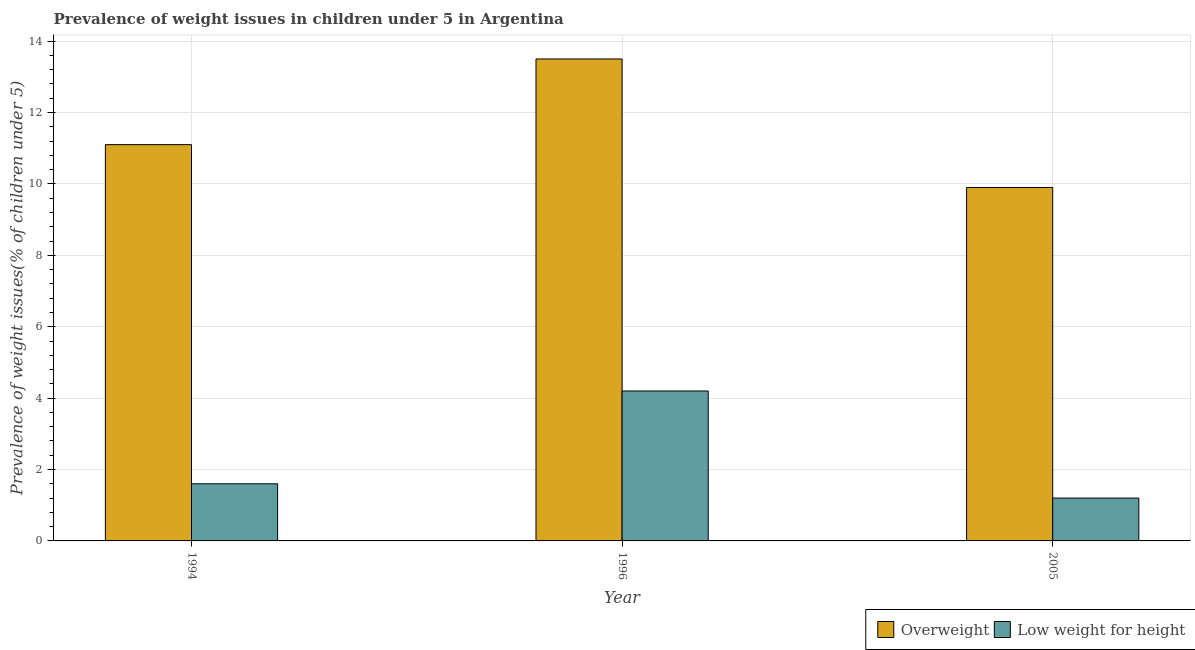Are the number of bars per tick equal to the number of legend labels?
Your response must be concise. Yes. Are the number of bars on each tick of the X-axis equal?
Make the answer very short. Yes. How many bars are there on the 3rd tick from the right?
Your response must be concise. 2. What is the label of the 2nd group of bars from the left?
Provide a succinct answer. 1996. In how many cases, is the number of bars for a given year not equal to the number of legend labels?
Offer a very short reply. 0. What is the percentage of underweight children in 2005?
Give a very brief answer. 1.2. Across all years, what is the minimum percentage of overweight children?
Make the answer very short. 9.9. In which year was the percentage of overweight children maximum?
Your response must be concise. 1996. What is the total percentage of underweight children in the graph?
Keep it short and to the point. 7. What is the difference between the percentage of overweight children in 1996 and that in 2005?
Offer a terse response. 3.6. What is the difference between the percentage of underweight children in 1994 and the percentage of overweight children in 2005?
Offer a terse response. 0.4. What is the average percentage of overweight children per year?
Make the answer very short. 11.5. In the year 1996, what is the difference between the percentage of underweight children and percentage of overweight children?
Ensure brevity in your answer.  0. What is the ratio of the percentage of underweight children in 1996 to that in 2005?
Your response must be concise. 3.5. Is the difference between the percentage of overweight children in 1994 and 2005 greater than the difference between the percentage of underweight children in 1994 and 2005?
Make the answer very short. No. What is the difference between the highest and the second highest percentage of underweight children?
Provide a succinct answer. 2.6. What is the difference between the highest and the lowest percentage of underweight children?
Give a very brief answer. 3. Is the sum of the percentage of overweight children in 1996 and 2005 greater than the maximum percentage of underweight children across all years?
Give a very brief answer. Yes. What does the 2nd bar from the left in 1994 represents?
Provide a short and direct response. Low weight for height. What does the 2nd bar from the right in 2005 represents?
Your answer should be very brief. Overweight. Are all the bars in the graph horizontal?
Keep it short and to the point. No. What is the difference between two consecutive major ticks on the Y-axis?
Ensure brevity in your answer.  2. Are the values on the major ticks of Y-axis written in scientific E-notation?
Make the answer very short. No. Does the graph contain grids?
Ensure brevity in your answer.  Yes. Where does the legend appear in the graph?
Make the answer very short. Bottom right. How are the legend labels stacked?
Keep it short and to the point. Horizontal. What is the title of the graph?
Make the answer very short. Prevalence of weight issues in children under 5 in Argentina. Does "Exports of goods" appear as one of the legend labels in the graph?
Keep it short and to the point. No. What is the label or title of the Y-axis?
Your answer should be compact. Prevalence of weight issues(% of children under 5). What is the Prevalence of weight issues(% of children under 5) of Overweight in 1994?
Ensure brevity in your answer.  11.1. What is the Prevalence of weight issues(% of children under 5) of Low weight for height in 1994?
Your answer should be compact. 1.6. What is the Prevalence of weight issues(% of children under 5) of Low weight for height in 1996?
Your answer should be very brief. 4.2. What is the Prevalence of weight issues(% of children under 5) in Overweight in 2005?
Your answer should be very brief. 9.9. What is the Prevalence of weight issues(% of children under 5) of Low weight for height in 2005?
Give a very brief answer. 1.2. Across all years, what is the maximum Prevalence of weight issues(% of children under 5) of Low weight for height?
Provide a succinct answer. 4.2. Across all years, what is the minimum Prevalence of weight issues(% of children under 5) in Overweight?
Offer a terse response. 9.9. Across all years, what is the minimum Prevalence of weight issues(% of children under 5) of Low weight for height?
Provide a succinct answer. 1.2. What is the total Prevalence of weight issues(% of children under 5) of Overweight in the graph?
Provide a short and direct response. 34.5. What is the difference between the Prevalence of weight issues(% of children under 5) in Low weight for height in 1994 and that in 2005?
Provide a short and direct response. 0.4. What is the difference between the Prevalence of weight issues(% of children under 5) in Low weight for height in 1996 and that in 2005?
Make the answer very short. 3. What is the difference between the Prevalence of weight issues(% of children under 5) of Overweight in 1994 and the Prevalence of weight issues(% of children under 5) of Low weight for height in 2005?
Provide a succinct answer. 9.9. What is the difference between the Prevalence of weight issues(% of children under 5) of Overweight in 1996 and the Prevalence of weight issues(% of children under 5) of Low weight for height in 2005?
Provide a short and direct response. 12.3. What is the average Prevalence of weight issues(% of children under 5) in Overweight per year?
Give a very brief answer. 11.5. What is the average Prevalence of weight issues(% of children under 5) in Low weight for height per year?
Your answer should be very brief. 2.33. In the year 1994, what is the difference between the Prevalence of weight issues(% of children under 5) of Overweight and Prevalence of weight issues(% of children under 5) of Low weight for height?
Provide a succinct answer. 9.5. In the year 1996, what is the difference between the Prevalence of weight issues(% of children under 5) in Overweight and Prevalence of weight issues(% of children under 5) in Low weight for height?
Keep it short and to the point. 9.3. What is the ratio of the Prevalence of weight issues(% of children under 5) in Overweight in 1994 to that in 1996?
Make the answer very short. 0.82. What is the ratio of the Prevalence of weight issues(% of children under 5) of Low weight for height in 1994 to that in 1996?
Offer a very short reply. 0.38. What is the ratio of the Prevalence of weight issues(% of children under 5) of Overweight in 1994 to that in 2005?
Your answer should be very brief. 1.12. What is the ratio of the Prevalence of weight issues(% of children under 5) in Low weight for height in 1994 to that in 2005?
Offer a terse response. 1.33. What is the ratio of the Prevalence of weight issues(% of children under 5) in Overweight in 1996 to that in 2005?
Your response must be concise. 1.36. What is the ratio of the Prevalence of weight issues(% of children under 5) in Low weight for height in 1996 to that in 2005?
Your answer should be compact. 3.5. What is the difference between the highest and the lowest Prevalence of weight issues(% of children under 5) of Overweight?
Offer a terse response. 3.6. 